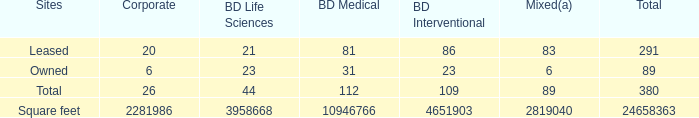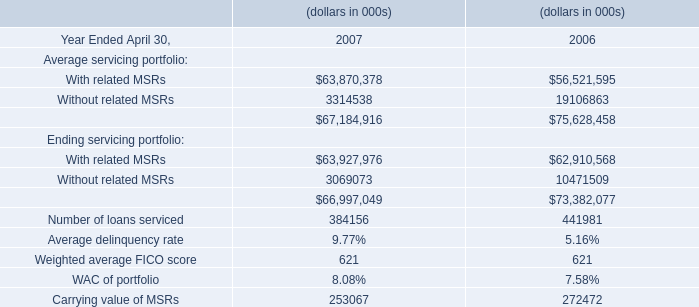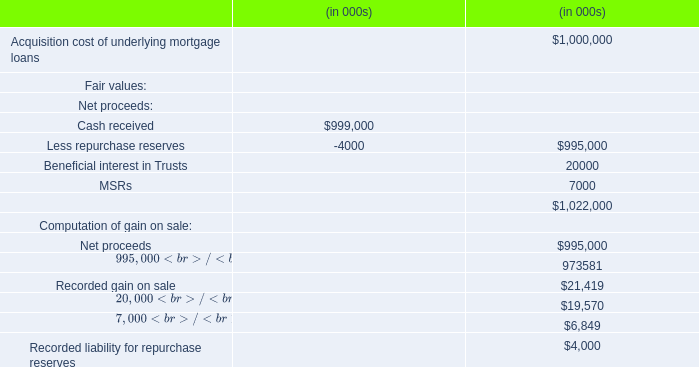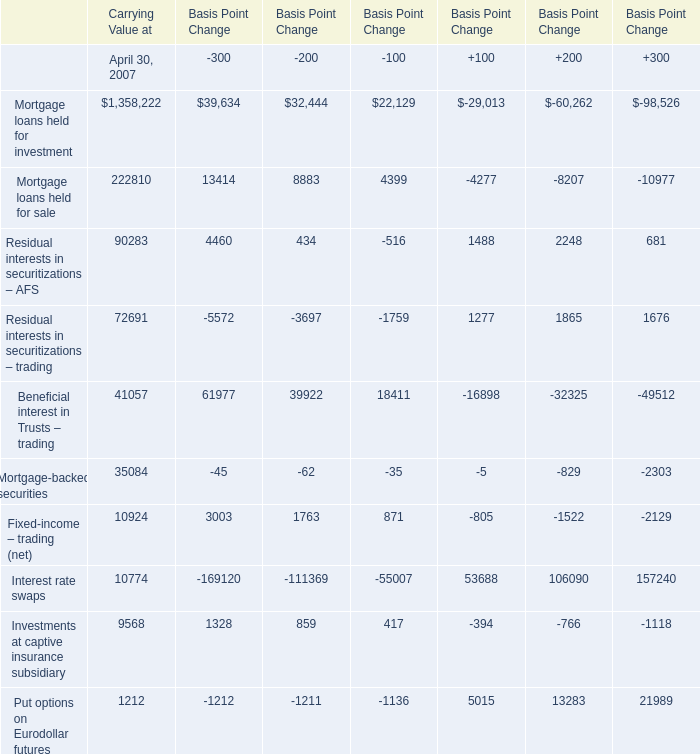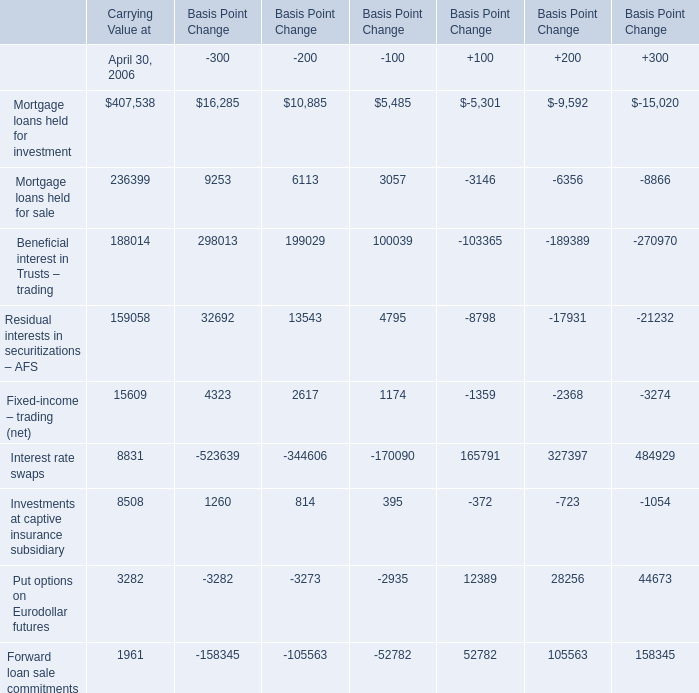In which year is Mortgage loans held for investment greater than 0? 
Answer: 2007. 